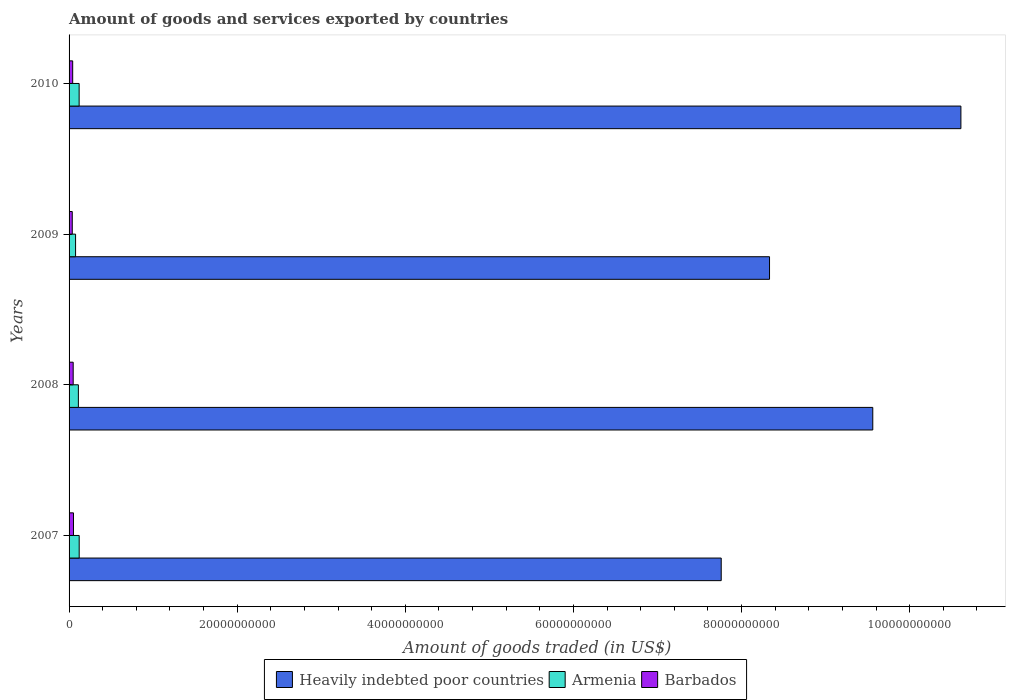How many different coloured bars are there?
Offer a terse response. 3. Are the number of bars per tick equal to the number of legend labels?
Provide a succinct answer. Yes. How many bars are there on the 3rd tick from the top?
Offer a terse response. 3. How many bars are there on the 2nd tick from the bottom?
Keep it short and to the point. 3. What is the label of the 1st group of bars from the top?
Make the answer very short. 2010. In how many cases, is the number of bars for a given year not equal to the number of legend labels?
Your answer should be compact. 0. What is the total amount of goods and services exported in Barbados in 2010?
Offer a very short reply. 4.31e+08. Across all years, what is the maximum total amount of goods and services exported in Heavily indebted poor countries?
Your answer should be compact. 1.06e+11. Across all years, what is the minimum total amount of goods and services exported in Armenia?
Provide a succinct answer. 7.74e+08. In which year was the total amount of goods and services exported in Barbados maximum?
Give a very brief answer. 2007. What is the total total amount of goods and services exported in Barbados in the graph?
Your response must be concise. 1.83e+09. What is the difference between the total amount of goods and services exported in Barbados in 2008 and that in 2009?
Ensure brevity in your answer.  1.09e+08. What is the difference between the total amount of goods and services exported in Heavily indebted poor countries in 2010 and the total amount of goods and services exported in Barbados in 2008?
Provide a succinct answer. 1.06e+11. What is the average total amount of goods and services exported in Barbados per year?
Give a very brief answer. 4.56e+08. In the year 2007, what is the difference between the total amount of goods and services exported in Armenia and total amount of goods and services exported in Heavily indebted poor countries?
Give a very brief answer. -7.64e+1. What is the ratio of the total amount of goods and services exported in Armenia in 2007 to that in 2010?
Your answer should be very brief. 1.01. Is the total amount of goods and services exported in Armenia in 2007 less than that in 2009?
Offer a terse response. No. What is the difference between the highest and the second highest total amount of goods and services exported in Barbados?
Keep it short and to the point. 3.60e+07. What is the difference between the highest and the lowest total amount of goods and services exported in Heavily indebted poor countries?
Make the answer very short. 2.85e+1. In how many years, is the total amount of goods and services exported in Barbados greater than the average total amount of goods and services exported in Barbados taken over all years?
Keep it short and to the point. 2. What does the 2nd bar from the top in 2007 represents?
Make the answer very short. Armenia. What does the 2nd bar from the bottom in 2008 represents?
Provide a short and direct response. Armenia. Is it the case that in every year, the sum of the total amount of goods and services exported in Armenia and total amount of goods and services exported in Barbados is greater than the total amount of goods and services exported in Heavily indebted poor countries?
Offer a very short reply. No. How many bars are there?
Your response must be concise. 12. Where does the legend appear in the graph?
Provide a short and direct response. Bottom center. How many legend labels are there?
Your response must be concise. 3. What is the title of the graph?
Provide a short and direct response. Amount of goods and services exported by countries. Does "Malawi" appear as one of the legend labels in the graph?
Provide a short and direct response. No. What is the label or title of the X-axis?
Provide a short and direct response. Amount of goods traded (in US$). What is the label or title of the Y-axis?
Offer a very short reply. Years. What is the Amount of goods traded (in US$) of Heavily indebted poor countries in 2007?
Provide a short and direct response. 7.76e+1. What is the Amount of goods traded (in US$) of Armenia in 2007?
Make the answer very short. 1.20e+09. What is the Amount of goods traded (in US$) of Barbados in 2007?
Ensure brevity in your answer.  5.25e+08. What is the Amount of goods traded (in US$) in Heavily indebted poor countries in 2008?
Offer a very short reply. 9.56e+1. What is the Amount of goods traded (in US$) in Armenia in 2008?
Offer a very short reply. 1.11e+09. What is the Amount of goods traded (in US$) of Barbados in 2008?
Give a very brief answer. 4.89e+08. What is the Amount of goods traded (in US$) in Heavily indebted poor countries in 2009?
Provide a short and direct response. 8.33e+1. What is the Amount of goods traded (in US$) in Armenia in 2009?
Keep it short and to the point. 7.74e+08. What is the Amount of goods traded (in US$) of Barbados in 2009?
Offer a terse response. 3.80e+08. What is the Amount of goods traded (in US$) in Heavily indebted poor countries in 2010?
Ensure brevity in your answer.  1.06e+11. What is the Amount of goods traded (in US$) of Armenia in 2010?
Offer a very short reply. 1.20e+09. What is the Amount of goods traded (in US$) in Barbados in 2010?
Give a very brief answer. 4.31e+08. Across all years, what is the maximum Amount of goods traded (in US$) of Heavily indebted poor countries?
Your answer should be compact. 1.06e+11. Across all years, what is the maximum Amount of goods traded (in US$) in Armenia?
Your response must be concise. 1.20e+09. Across all years, what is the maximum Amount of goods traded (in US$) in Barbados?
Offer a very short reply. 5.25e+08. Across all years, what is the minimum Amount of goods traded (in US$) of Heavily indebted poor countries?
Your answer should be compact. 7.76e+1. Across all years, what is the minimum Amount of goods traded (in US$) of Armenia?
Your answer should be compact. 7.74e+08. Across all years, what is the minimum Amount of goods traded (in US$) of Barbados?
Provide a succinct answer. 3.80e+08. What is the total Amount of goods traded (in US$) of Heavily indebted poor countries in the graph?
Make the answer very short. 3.63e+11. What is the total Amount of goods traded (in US$) in Armenia in the graph?
Your answer should be very brief. 4.28e+09. What is the total Amount of goods traded (in US$) in Barbados in the graph?
Offer a very short reply. 1.83e+09. What is the difference between the Amount of goods traded (in US$) of Heavily indebted poor countries in 2007 and that in 2008?
Make the answer very short. -1.80e+1. What is the difference between the Amount of goods traded (in US$) of Armenia in 2007 and that in 2008?
Offer a terse response. 9.79e+07. What is the difference between the Amount of goods traded (in US$) in Barbados in 2007 and that in 2008?
Your answer should be very brief. 3.60e+07. What is the difference between the Amount of goods traded (in US$) of Heavily indebted poor countries in 2007 and that in 2009?
Ensure brevity in your answer.  -5.75e+09. What is the difference between the Amount of goods traded (in US$) in Armenia in 2007 and that in 2009?
Your answer should be very brief. 4.31e+08. What is the difference between the Amount of goods traded (in US$) in Barbados in 2007 and that in 2009?
Your answer should be very brief. 1.45e+08. What is the difference between the Amount of goods traded (in US$) in Heavily indebted poor countries in 2007 and that in 2010?
Give a very brief answer. -2.85e+1. What is the difference between the Amount of goods traded (in US$) in Armenia in 2007 and that in 2010?
Give a very brief answer. 6.75e+06. What is the difference between the Amount of goods traded (in US$) in Barbados in 2007 and that in 2010?
Your answer should be very brief. 9.48e+07. What is the difference between the Amount of goods traded (in US$) in Heavily indebted poor countries in 2008 and that in 2009?
Keep it short and to the point. 1.23e+1. What is the difference between the Amount of goods traded (in US$) of Armenia in 2008 and that in 2009?
Your answer should be very brief. 3.33e+08. What is the difference between the Amount of goods traded (in US$) of Barbados in 2008 and that in 2009?
Offer a terse response. 1.09e+08. What is the difference between the Amount of goods traded (in US$) of Heavily indebted poor countries in 2008 and that in 2010?
Keep it short and to the point. -1.05e+1. What is the difference between the Amount of goods traded (in US$) in Armenia in 2008 and that in 2010?
Your answer should be very brief. -9.12e+07. What is the difference between the Amount of goods traded (in US$) of Barbados in 2008 and that in 2010?
Offer a very short reply. 5.88e+07. What is the difference between the Amount of goods traded (in US$) in Heavily indebted poor countries in 2009 and that in 2010?
Give a very brief answer. -2.28e+1. What is the difference between the Amount of goods traded (in US$) in Armenia in 2009 and that in 2010?
Offer a very short reply. -4.24e+08. What is the difference between the Amount of goods traded (in US$) in Barbados in 2009 and that in 2010?
Your answer should be very brief. -5.04e+07. What is the difference between the Amount of goods traded (in US$) in Heavily indebted poor countries in 2007 and the Amount of goods traded (in US$) in Armenia in 2008?
Your answer should be very brief. 7.65e+1. What is the difference between the Amount of goods traded (in US$) of Heavily indebted poor countries in 2007 and the Amount of goods traded (in US$) of Barbados in 2008?
Give a very brief answer. 7.71e+1. What is the difference between the Amount of goods traded (in US$) of Armenia in 2007 and the Amount of goods traded (in US$) of Barbados in 2008?
Offer a very short reply. 7.15e+08. What is the difference between the Amount of goods traded (in US$) in Heavily indebted poor countries in 2007 and the Amount of goods traded (in US$) in Armenia in 2009?
Your answer should be very brief. 7.68e+1. What is the difference between the Amount of goods traded (in US$) in Heavily indebted poor countries in 2007 and the Amount of goods traded (in US$) in Barbados in 2009?
Your answer should be compact. 7.72e+1. What is the difference between the Amount of goods traded (in US$) in Armenia in 2007 and the Amount of goods traded (in US$) in Barbados in 2009?
Offer a terse response. 8.24e+08. What is the difference between the Amount of goods traded (in US$) in Heavily indebted poor countries in 2007 and the Amount of goods traded (in US$) in Armenia in 2010?
Your answer should be very brief. 7.64e+1. What is the difference between the Amount of goods traded (in US$) in Heavily indebted poor countries in 2007 and the Amount of goods traded (in US$) in Barbados in 2010?
Your answer should be very brief. 7.71e+1. What is the difference between the Amount of goods traded (in US$) in Armenia in 2007 and the Amount of goods traded (in US$) in Barbados in 2010?
Give a very brief answer. 7.74e+08. What is the difference between the Amount of goods traded (in US$) in Heavily indebted poor countries in 2008 and the Amount of goods traded (in US$) in Armenia in 2009?
Offer a terse response. 9.48e+1. What is the difference between the Amount of goods traded (in US$) in Heavily indebted poor countries in 2008 and the Amount of goods traded (in US$) in Barbados in 2009?
Provide a short and direct response. 9.52e+1. What is the difference between the Amount of goods traded (in US$) of Armenia in 2008 and the Amount of goods traded (in US$) of Barbados in 2009?
Give a very brief answer. 7.26e+08. What is the difference between the Amount of goods traded (in US$) of Heavily indebted poor countries in 2008 and the Amount of goods traded (in US$) of Armenia in 2010?
Provide a short and direct response. 9.44e+1. What is the difference between the Amount of goods traded (in US$) in Heavily indebted poor countries in 2008 and the Amount of goods traded (in US$) in Barbados in 2010?
Ensure brevity in your answer.  9.52e+1. What is the difference between the Amount of goods traded (in US$) of Armenia in 2008 and the Amount of goods traded (in US$) of Barbados in 2010?
Offer a very short reply. 6.76e+08. What is the difference between the Amount of goods traded (in US$) of Heavily indebted poor countries in 2009 and the Amount of goods traded (in US$) of Armenia in 2010?
Offer a very short reply. 8.21e+1. What is the difference between the Amount of goods traded (in US$) in Heavily indebted poor countries in 2009 and the Amount of goods traded (in US$) in Barbados in 2010?
Give a very brief answer. 8.29e+1. What is the difference between the Amount of goods traded (in US$) of Armenia in 2009 and the Amount of goods traded (in US$) of Barbados in 2010?
Your answer should be compact. 3.43e+08. What is the average Amount of goods traded (in US$) in Heavily indebted poor countries per year?
Your answer should be compact. 9.07e+1. What is the average Amount of goods traded (in US$) in Armenia per year?
Make the answer very short. 1.07e+09. What is the average Amount of goods traded (in US$) in Barbados per year?
Keep it short and to the point. 4.56e+08. In the year 2007, what is the difference between the Amount of goods traded (in US$) of Heavily indebted poor countries and Amount of goods traded (in US$) of Armenia?
Provide a succinct answer. 7.64e+1. In the year 2007, what is the difference between the Amount of goods traded (in US$) of Heavily indebted poor countries and Amount of goods traded (in US$) of Barbados?
Provide a short and direct response. 7.71e+1. In the year 2007, what is the difference between the Amount of goods traded (in US$) of Armenia and Amount of goods traded (in US$) of Barbados?
Offer a terse response. 6.79e+08. In the year 2008, what is the difference between the Amount of goods traded (in US$) in Heavily indebted poor countries and Amount of goods traded (in US$) in Armenia?
Keep it short and to the point. 9.45e+1. In the year 2008, what is the difference between the Amount of goods traded (in US$) of Heavily indebted poor countries and Amount of goods traded (in US$) of Barbados?
Provide a succinct answer. 9.51e+1. In the year 2008, what is the difference between the Amount of goods traded (in US$) in Armenia and Amount of goods traded (in US$) in Barbados?
Make the answer very short. 6.17e+08. In the year 2009, what is the difference between the Amount of goods traded (in US$) in Heavily indebted poor countries and Amount of goods traded (in US$) in Armenia?
Provide a short and direct response. 8.26e+1. In the year 2009, what is the difference between the Amount of goods traded (in US$) of Heavily indebted poor countries and Amount of goods traded (in US$) of Barbados?
Offer a very short reply. 8.29e+1. In the year 2009, what is the difference between the Amount of goods traded (in US$) of Armenia and Amount of goods traded (in US$) of Barbados?
Give a very brief answer. 3.93e+08. In the year 2010, what is the difference between the Amount of goods traded (in US$) of Heavily indebted poor countries and Amount of goods traded (in US$) of Armenia?
Offer a very short reply. 1.05e+11. In the year 2010, what is the difference between the Amount of goods traded (in US$) of Heavily indebted poor countries and Amount of goods traded (in US$) of Barbados?
Your response must be concise. 1.06e+11. In the year 2010, what is the difference between the Amount of goods traded (in US$) in Armenia and Amount of goods traded (in US$) in Barbados?
Your answer should be compact. 7.67e+08. What is the ratio of the Amount of goods traded (in US$) of Heavily indebted poor countries in 2007 to that in 2008?
Offer a very short reply. 0.81. What is the ratio of the Amount of goods traded (in US$) of Armenia in 2007 to that in 2008?
Offer a very short reply. 1.09. What is the ratio of the Amount of goods traded (in US$) of Barbados in 2007 to that in 2008?
Provide a succinct answer. 1.07. What is the ratio of the Amount of goods traded (in US$) in Armenia in 2007 to that in 2009?
Your answer should be compact. 1.56. What is the ratio of the Amount of goods traded (in US$) of Barbados in 2007 to that in 2009?
Offer a very short reply. 1.38. What is the ratio of the Amount of goods traded (in US$) in Heavily indebted poor countries in 2007 to that in 2010?
Ensure brevity in your answer.  0.73. What is the ratio of the Amount of goods traded (in US$) in Armenia in 2007 to that in 2010?
Give a very brief answer. 1.01. What is the ratio of the Amount of goods traded (in US$) in Barbados in 2007 to that in 2010?
Offer a very short reply. 1.22. What is the ratio of the Amount of goods traded (in US$) of Heavily indebted poor countries in 2008 to that in 2009?
Give a very brief answer. 1.15. What is the ratio of the Amount of goods traded (in US$) of Armenia in 2008 to that in 2009?
Provide a short and direct response. 1.43. What is the ratio of the Amount of goods traded (in US$) in Barbados in 2008 to that in 2009?
Provide a succinct answer. 1.29. What is the ratio of the Amount of goods traded (in US$) of Heavily indebted poor countries in 2008 to that in 2010?
Give a very brief answer. 0.9. What is the ratio of the Amount of goods traded (in US$) of Armenia in 2008 to that in 2010?
Give a very brief answer. 0.92. What is the ratio of the Amount of goods traded (in US$) in Barbados in 2008 to that in 2010?
Offer a very short reply. 1.14. What is the ratio of the Amount of goods traded (in US$) in Heavily indebted poor countries in 2009 to that in 2010?
Your response must be concise. 0.79. What is the ratio of the Amount of goods traded (in US$) of Armenia in 2009 to that in 2010?
Give a very brief answer. 0.65. What is the ratio of the Amount of goods traded (in US$) of Barbados in 2009 to that in 2010?
Ensure brevity in your answer.  0.88. What is the difference between the highest and the second highest Amount of goods traded (in US$) of Heavily indebted poor countries?
Your response must be concise. 1.05e+1. What is the difference between the highest and the second highest Amount of goods traded (in US$) in Armenia?
Your response must be concise. 6.75e+06. What is the difference between the highest and the second highest Amount of goods traded (in US$) of Barbados?
Keep it short and to the point. 3.60e+07. What is the difference between the highest and the lowest Amount of goods traded (in US$) of Heavily indebted poor countries?
Give a very brief answer. 2.85e+1. What is the difference between the highest and the lowest Amount of goods traded (in US$) of Armenia?
Give a very brief answer. 4.31e+08. What is the difference between the highest and the lowest Amount of goods traded (in US$) in Barbados?
Your response must be concise. 1.45e+08. 